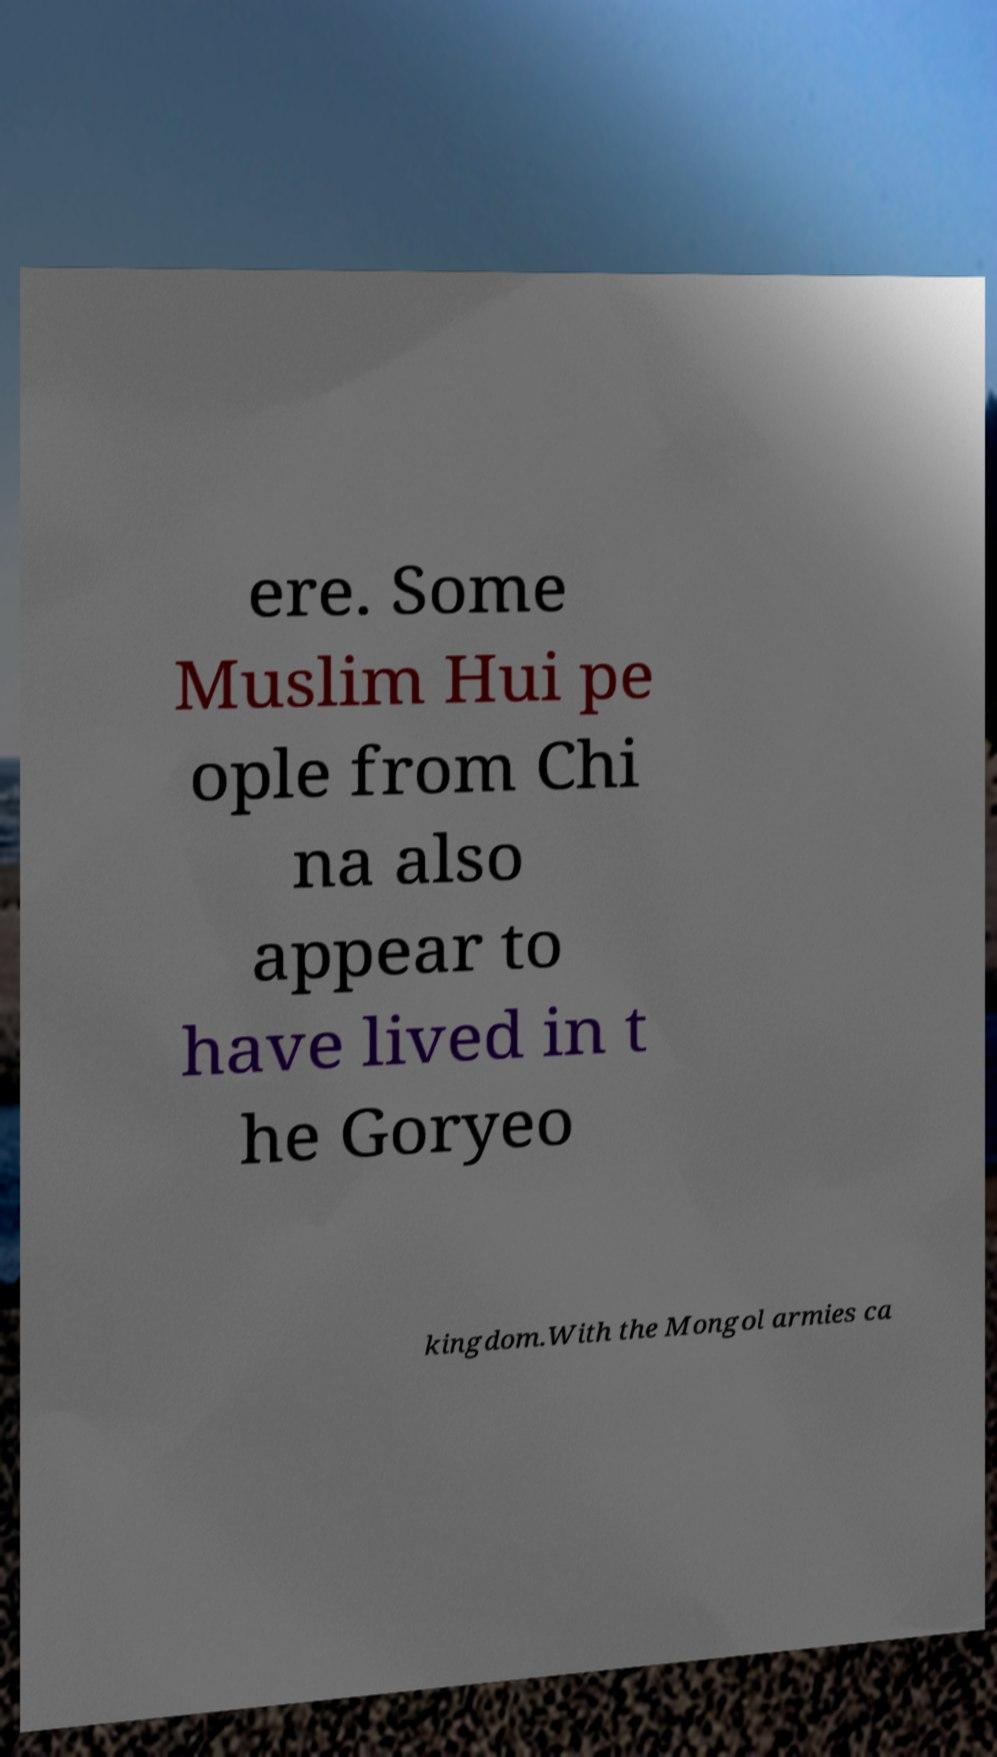Could you assist in decoding the text presented in this image and type it out clearly? ere. Some Muslim Hui pe ople from Chi na also appear to have lived in t he Goryeo kingdom.With the Mongol armies ca 